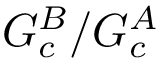<formula> <loc_0><loc_0><loc_500><loc_500>G _ { c } ^ { B } / G _ { c } ^ { A }</formula> 